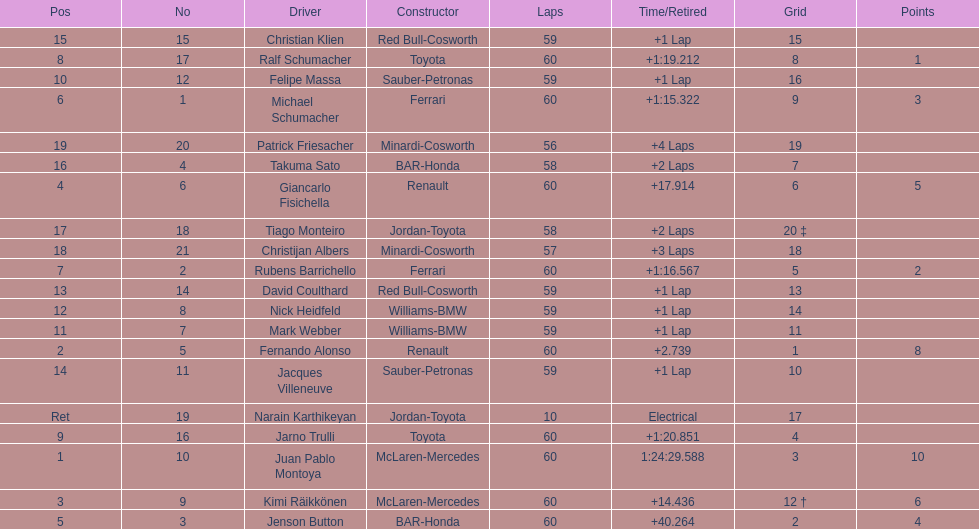After 8th position, how many points does a driver receive? 0. 